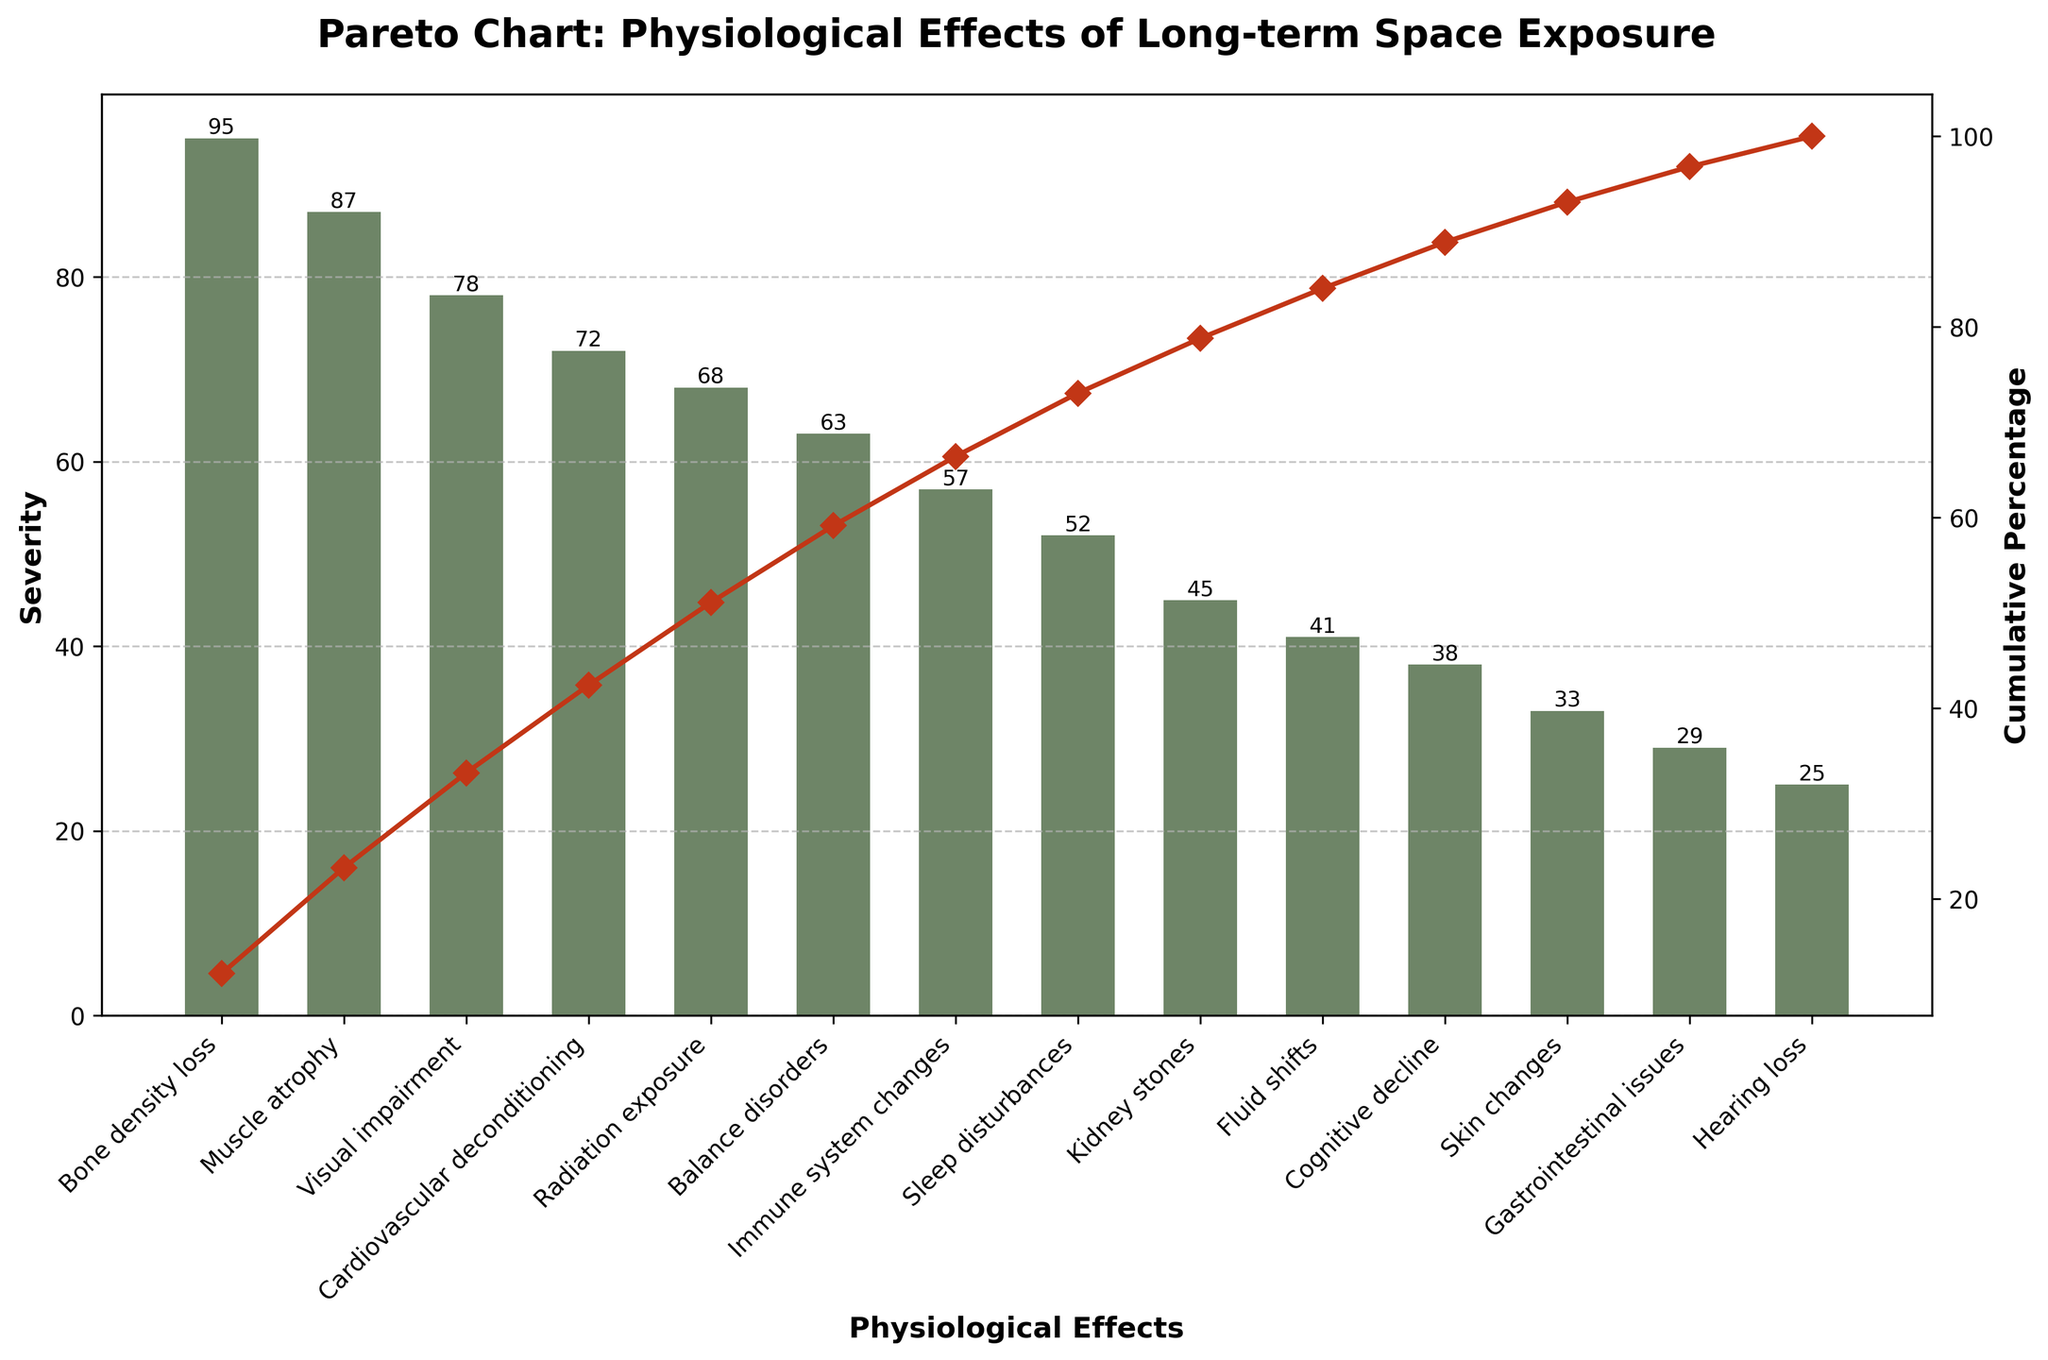What's the title of the figure? The title is typically located at the top of the figure, summarizing its content. It reads "Pareto Chart: Physiological Effects of Long-term Space Exposure".
Answer: Pareto Chart: Physiological Effects of Long-term Space Exposure How many physiological effects are listed in the figure? By counting the number of bars on the chart, we can determine the number of physiological effects represented. These bars correspond to individual effects on the x-axis.
Answer: 14 Which physiological effect has the highest severity? The tallest bar on the chart indicates the effect with the highest severity. This bar represents "Bone density loss".
Answer: Bone density loss What is the cumulative percentage for "Visual impairment"? Locate the bar for "Visual impairment" on the x-axis and find where it intersects the cumulative percentage line. This point on the y-axis for the secondary axis gives the cumulative percentage.
Answer: 74.3% Which physiological effect has the least severity? The shortest bar on the chart corresponds to the effect with the least severity, which is "Hearing loss".
Answer: Hearing loss What can be inferred about "Muscle atrophy" and "Visual impairment" in terms of severity? Compare the heights of the bars for "Muscle atrophy" and "Visual impairment". "Muscle atrophy" has a taller bar, thus a higher severity than "Visual impairment".
Answer: Muscle atrophy has higher severity than Visual impairment What is the difference in severity between "Radiation exposure" and "Sleep disturbances"? Subtract the severity of "Sleep disturbances" from that of "Radiation exposure" using their corresponding bar heights.
Answer: 16 Which effects contribute to over 50% of the total severity? Trace the cumulative percentage line up to the 50% mark on the secondary y-axis and note the effects before this point. These effects are "Bone density loss" and "Muscle atrophy".
Answer: Bone density loss, Muscle atrophy How does the severity of "Balance disorders" compare to "Fluid shifts"? Observe the bar heights for both "Balance disorders" and "Fluid shifts". "Balance disorders" has a taller bar indicating higher severity than "Fluid shifts".
Answer: Balance disorders is higher than Fluid shifts Which physiological effects together make up the cumulative percentage of approximately 80%? Follow the cumulative percentage line to 80% and identify the bars before this point. These bars represent the physiological effects.
Answer: Bone density loss, Muscle atrophy, Visual impairment, Cardiovascular deconditioning, Radiation exposure, Balance disorders 